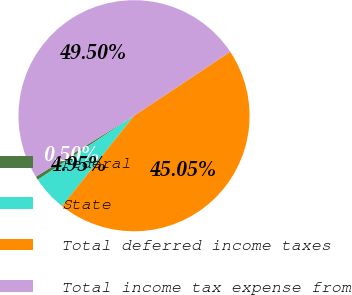Convert chart. <chart><loc_0><loc_0><loc_500><loc_500><pie_chart><fcel>Federal<fcel>State<fcel>Total deferred income taxes<fcel>Total income tax expense from<nl><fcel>0.5%<fcel>4.95%<fcel>45.05%<fcel>49.5%<nl></chart> 